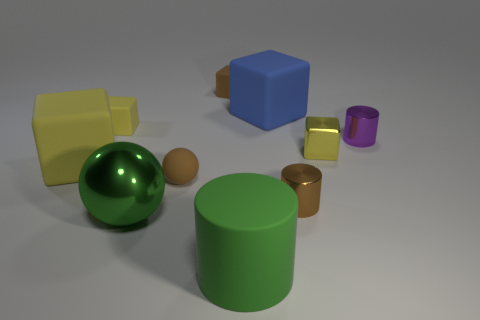How many other things are there of the same material as the big green sphere?
Make the answer very short. 3. There is a blue matte object that is the same shape as the tiny yellow metal thing; what is its size?
Your response must be concise. Large. There is a big block that is to the right of the large cube on the left side of the tiny brown matte thing that is in front of the shiny cube; what is it made of?
Provide a short and direct response. Rubber. Are any large yellow cubes visible?
Ensure brevity in your answer.  Yes. Do the metal block and the block behind the blue cube have the same color?
Ensure brevity in your answer.  No. The tiny matte ball has what color?
Keep it short and to the point. Brown. Is there any other thing that has the same shape as the big yellow matte object?
Provide a succinct answer. Yes. There is another small metal object that is the same shape as the brown shiny thing; what color is it?
Provide a succinct answer. Purple. Is the shape of the tiny yellow shiny object the same as the large green matte thing?
Keep it short and to the point. No. What number of spheres are either yellow shiny objects or tiny brown matte things?
Offer a very short reply. 1. 